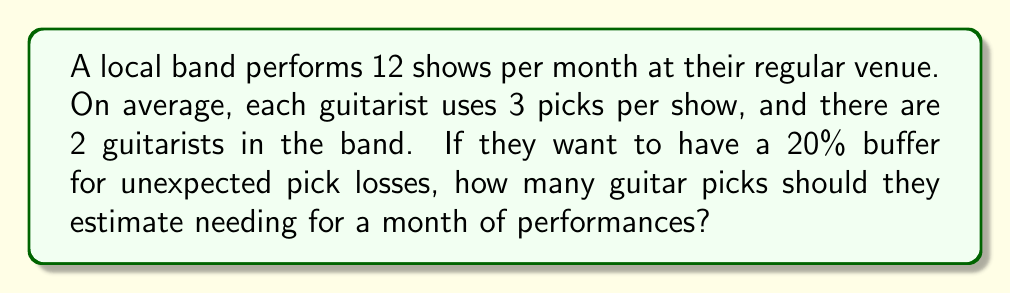Show me your answer to this math problem. Let's break this down step-by-step:

1. Calculate the number of picks used per show:
   $$ \text{Picks per show} = \text{Guitarists} \times \text{Picks per guitarist} = 2 \times 3 = 6 $$

2. Calculate the number of picks used per month:
   $$ \text{Picks per month} = \text{Picks per show} \times \text{Shows per month} = 6 \times 12 = 72 $$

3. Add a 20% buffer for unexpected losses:
   $$ \text{Buffer} = 20\% \text{ of } 72 = 0.2 \times 72 = 14.4 $$

4. Calculate the total estimated picks needed:
   $$ \text{Total picks} = \text{Picks per month} + \text{Buffer} = 72 + 14.4 = 86.4 $$

5. Round up to the nearest whole number, as you can't buy a fraction of a pick:
   $$ \text{Final estimate} = \lceil 86.4 \rceil = 87 $$
Answer: 87 picks 